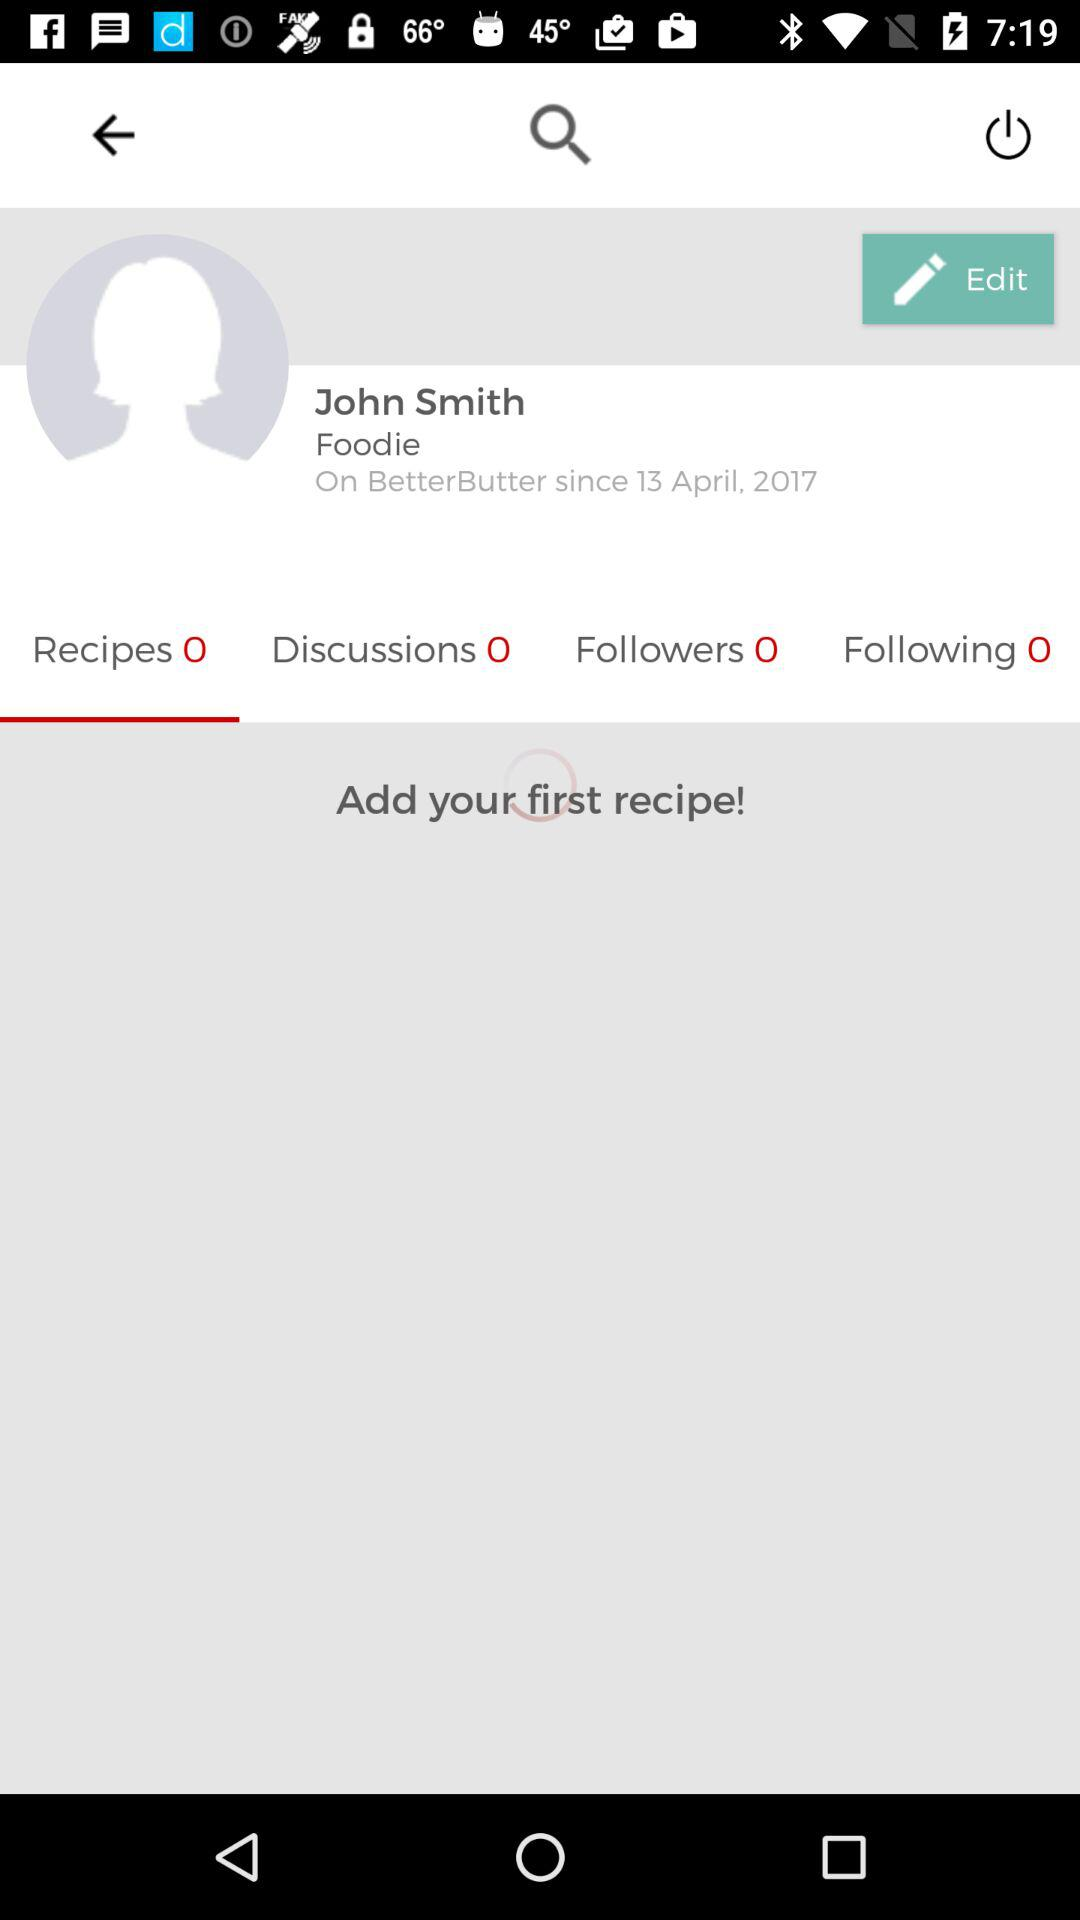Is there any recipe added?
When the provided information is insufficient, respond with <no answer>. <no answer> 